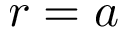Convert formula to latex. <formula><loc_0><loc_0><loc_500><loc_500>r = a</formula> 